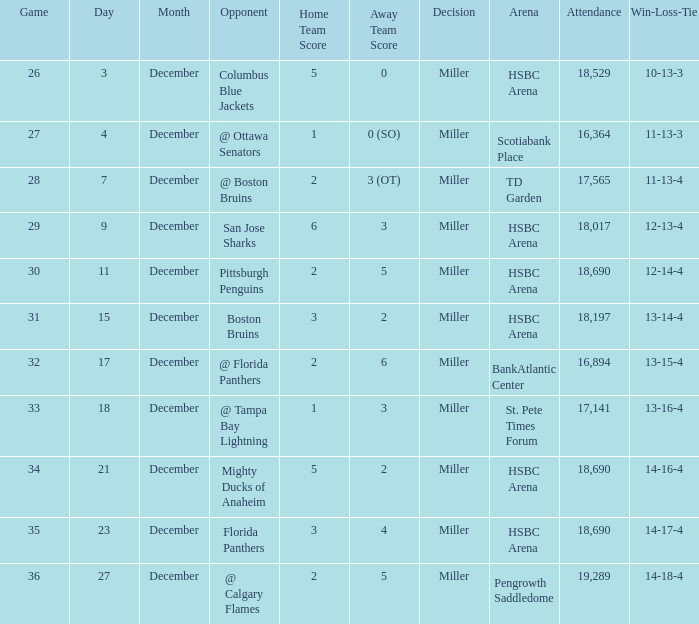Name the opponent for record 10-13-3 Columbus Blue Jackets. 